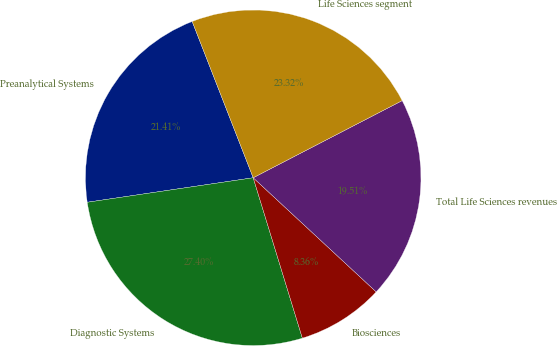Convert chart to OTSL. <chart><loc_0><loc_0><loc_500><loc_500><pie_chart><fcel>Preanalytical Systems<fcel>Diagnostic Systems<fcel>Biosciences<fcel>Total Life Sciences revenues<fcel>Life Sciences segment<nl><fcel>21.41%<fcel>27.4%<fcel>8.36%<fcel>19.51%<fcel>23.32%<nl></chart> 